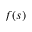<formula> <loc_0><loc_0><loc_500><loc_500>f ( s )</formula> 